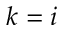<formula> <loc_0><loc_0><loc_500><loc_500>k = i</formula> 